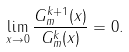Convert formula to latex. <formula><loc_0><loc_0><loc_500><loc_500>\lim _ { x \to 0 } \frac { G ^ { k + 1 } _ { m } ( x ) } { G ^ { k } _ { m } ( x ) } = 0 .</formula> 